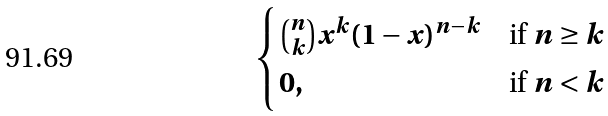Convert formula to latex. <formula><loc_0><loc_0><loc_500><loc_500>\begin{cases} \binom { n } { k } x ^ { k } ( 1 - x ) ^ { n - k } & \text {if } n \geq k \\ 0 , & \text {if } n < k \end{cases}</formula> 